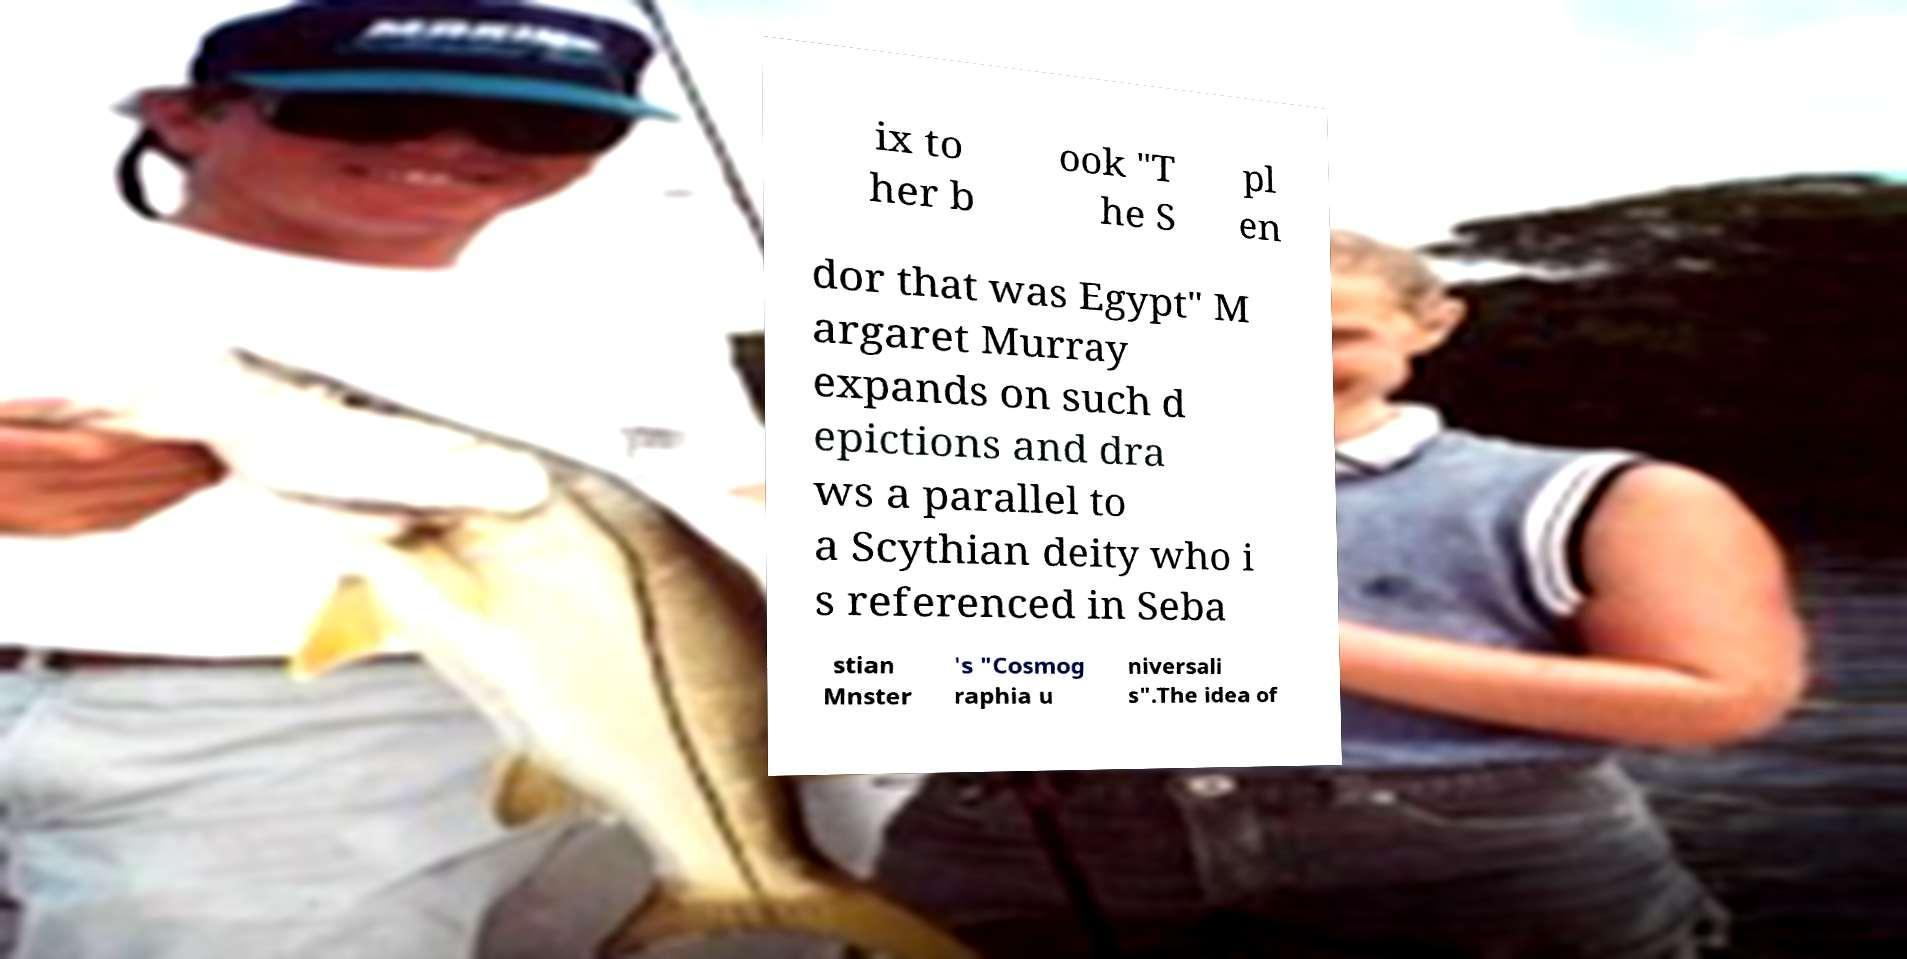Could you assist in decoding the text presented in this image and type it out clearly? ix to her b ook "T he S pl en dor that was Egypt" M argaret Murray expands on such d epictions and dra ws a parallel to a Scythian deity who i s referenced in Seba stian Mnster 's "Cosmog raphia u niversali s".The idea of 